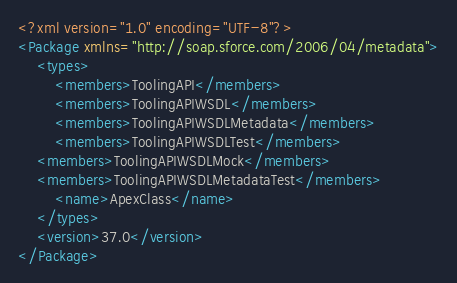Convert code to text. <code><loc_0><loc_0><loc_500><loc_500><_XML_><?xml version="1.0" encoding="UTF-8"?>
<Package xmlns="http://soap.sforce.com/2006/04/metadata">
    <types>
        <members>ToolingAPI</members>
        <members>ToolingAPIWSDL</members>
        <members>ToolingAPIWSDLMetadata</members>
        <members>ToolingAPIWSDLTest</members>
	<members>ToolingAPIWSDLMock</members>
	<members>ToolingAPIWSDLMetadataTest</members>
        <name>ApexClass</name>
    </types>
    <version>37.0</version>
</Package>
</code> 